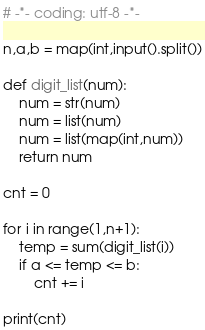<code> <loc_0><loc_0><loc_500><loc_500><_Python_># -*- coding: utf-8 -*-

n,a,b = map(int,input().split())

def digit_list(num):
    num = str(num)
    num = list(num)
    num = list(map(int,num))
    return num

cnt = 0

for i in range(1,n+1):
    temp = sum(digit_list(i))
    if a <= temp <= b:
        cnt += i

print(cnt)
</code> 